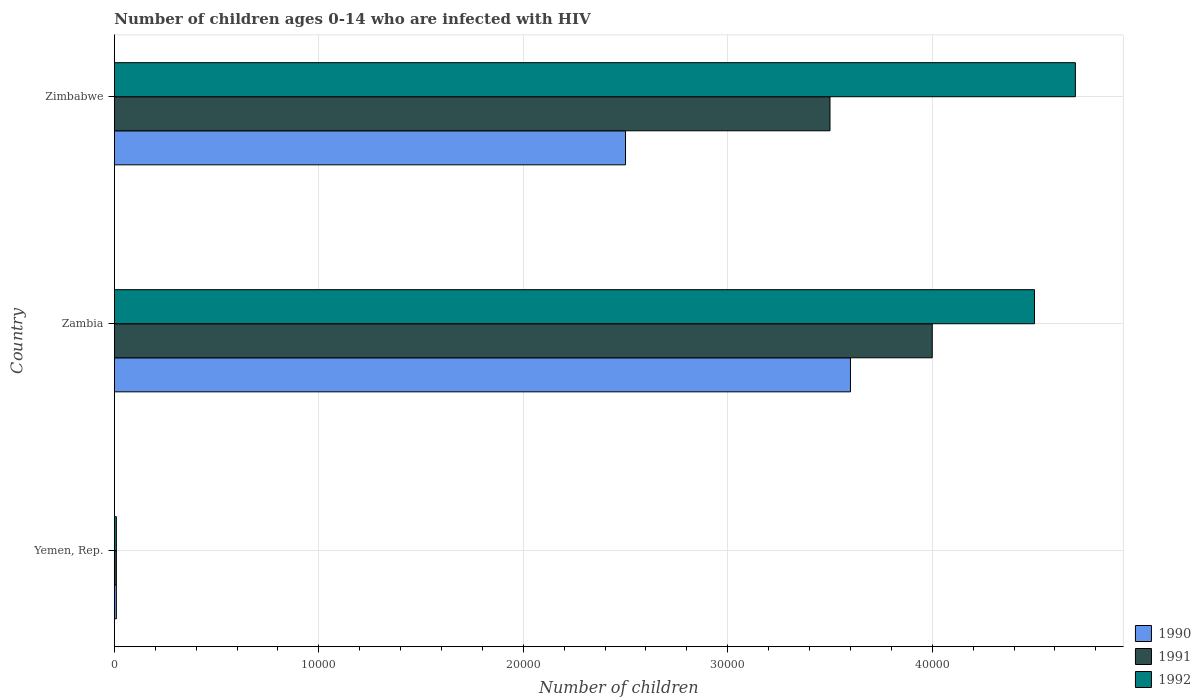How many bars are there on the 1st tick from the top?
Offer a very short reply. 3. What is the label of the 3rd group of bars from the top?
Your answer should be compact. Yemen, Rep. In how many cases, is the number of bars for a given country not equal to the number of legend labels?
Ensure brevity in your answer.  0. What is the number of HIV infected children in 1991 in Zimbabwe?
Offer a very short reply. 3.50e+04. Across all countries, what is the maximum number of HIV infected children in 1992?
Provide a short and direct response. 4.70e+04. Across all countries, what is the minimum number of HIV infected children in 1991?
Offer a terse response. 100. In which country was the number of HIV infected children in 1992 maximum?
Your answer should be very brief. Zimbabwe. In which country was the number of HIV infected children in 1992 minimum?
Keep it short and to the point. Yemen, Rep. What is the total number of HIV infected children in 1992 in the graph?
Offer a very short reply. 9.21e+04. What is the difference between the number of HIV infected children in 1990 in Yemen, Rep. and that in Zimbabwe?
Your response must be concise. -2.49e+04. What is the difference between the number of HIV infected children in 1992 in Yemen, Rep. and the number of HIV infected children in 1990 in Zambia?
Provide a succinct answer. -3.59e+04. What is the average number of HIV infected children in 1990 per country?
Keep it short and to the point. 2.04e+04. What is the difference between the number of HIV infected children in 1990 and number of HIV infected children in 1991 in Zambia?
Give a very brief answer. -4000. What is the ratio of the number of HIV infected children in 1991 in Yemen, Rep. to that in Zambia?
Keep it short and to the point. 0. Is the number of HIV infected children in 1990 in Yemen, Rep. less than that in Zimbabwe?
Your answer should be very brief. Yes. Is the difference between the number of HIV infected children in 1990 in Yemen, Rep. and Zambia greater than the difference between the number of HIV infected children in 1991 in Yemen, Rep. and Zambia?
Ensure brevity in your answer.  Yes. What is the difference between the highest and the second highest number of HIV infected children in 1990?
Make the answer very short. 1.10e+04. What is the difference between the highest and the lowest number of HIV infected children in 1990?
Keep it short and to the point. 3.59e+04. In how many countries, is the number of HIV infected children in 1991 greater than the average number of HIV infected children in 1991 taken over all countries?
Provide a succinct answer. 2. Is the sum of the number of HIV infected children in 1992 in Yemen, Rep. and Zimbabwe greater than the maximum number of HIV infected children in 1991 across all countries?
Provide a short and direct response. Yes. What does the 2nd bar from the top in Yemen, Rep. represents?
Ensure brevity in your answer.  1991. How many bars are there?
Provide a succinct answer. 9. How many countries are there in the graph?
Give a very brief answer. 3. What is the difference between two consecutive major ticks on the X-axis?
Provide a succinct answer. 10000. Are the values on the major ticks of X-axis written in scientific E-notation?
Your answer should be very brief. No. Does the graph contain any zero values?
Your answer should be compact. No. Does the graph contain grids?
Your response must be concise. Yes. How are the legend labels stacked?
Your answer should be very brief. Vertical. What is the title of the graph?
Your answer should be compact. Number of children ages 0-14 who are infected with HIV. Does "2000" appear as one of the legend labels in the graph?
Offer a very short reply. No. What is the label or title of the X-axis?
Your answer should be compact. Number of children. What is the label or title of the Y-axis?
Your response must be concise. Country. What is the Number of children of 1990 in Yemen, Rep.?
Keep it short and to the point. 100. What is the Number of children in 1992 in Yemen, Rep.?
Your response must be concise. 100. What is the Number of children in 1990 in Zambia?
Your answer should be compact. 3.60e+04. What is the Number of children of 1991 in Zambia?
Give a very brief answer. 4.00e+04. What is the Number of children of 1992 in Zambia?
Offer a very short reply. 4.50e+04. What is the Number of children of 1990 in Zimbabwe?
Make the answer very short. 2.50e+04. What is the Number of children in 1991 in Zimbabwe?
Ensure brevity in your answer.  3.50e+04. What is the Number of children in 1992 in Zimbabwe?
Offer a very short reply. 4.70e+04. Across all countries, what is the maximum Number of children of 1990?
Offer a terse response. 3.60e+04. Across all countries, what is the maximum Number of children in 1992?
Your response must be concise. 4.70e+04. What is the total Number of children of 1990 in the graph?
Keep it short and to the point. 6.11e+04. What is the total Number of children in 1991 in the graph?
Your response must be concise. 7.51e+04. What is the total Number of children in 1992 in the graph?
Offer a terse response. 9.21e+04. What is the difference between the Number of children of 1990 in Yemen, Rep. and that in Zambia?
Offer a very short reply. -3.59e+04. What is the difference between the Number of children of 1991 in Yemen, Rep. and that in Zambia?
Offer a very short reply. -3.99e+04. What is the difference between the Number of children of 1992 in Yemen, Rep. and that in Zambia?
Offer a terse response. -4.49e+04. What is the difference between the Number of children of 1990 in Yemen, Rep. and that in Zimbabwe?
Offer a terse response. -2.49e+04. What is the difference between the Number of children of 1991 in Yemen, Rep. and that in Zimbabwe?
Ensure brevity in your answer.  -3.49e+04. What is the difference between the Number of children of 1992 in Yemen, Rep. and that in Zimbabwe?
Give a very brief answer. -4.69e+04. What is the difference between the Number of children in 1990 in Zambia and that in Zimbabwe?
Provide a short and direct response. 1.10e+04. What is the difference between the Number of children of 1991 in Zambia and that in Zimbabwe?
Ensure brevity in your answer.  5000. What is the difference between the Number of children of 1992 in Zambia and that in Zimbabwe?
Make the answer very short. -2000. What is the difference between the Number of children in 1990 in Yemen, Rep. and the Number of children in 1991 in Zambia?
Your response must be concise. -3.99e+04. What is the difference between the Number of children in 1990 in Yemen, Rep. and the Number of children in 1992 in Zambia?
Your answer should be very brief. -4.49e+04. What is the difference between the Number of children in 1991 in Yemen, Rep. and the Number of children in 1992 in Zambia?
Offer a terse response. -4.49e+04. What is the difference between the Number of children in 1990 in Yemen, Rep. and the Number of children in 1991 in Zimbabwe?
Your answer should be very brief. -3.49e+04. What is the difference between the Number of children in 1990 in Yemen, Rep. and the Number of children in 1992 in Zimbabwe?
Your answer should be very brief. -4.69e+04. What is the difference between the Number of children of 1991 in Yemen, Rep. and the Number of children of 1992 in Zimbabwe?
Provide a short and direct response. -4.69e+04. What is the difference between the Number of children of 1990 in Zambia and the Number of children of 1992 in Zimbabwe?
Ensure brevity in your answer.  -1.10e+04. What is the difference between the Number of children of 1991 in Zambia and the Number of children of 1992 in Zimbabwe?
Provide a succinct answer. -7000. What is the average Number of children of 1990 per country?
Offer a terse response. 2.04e+04. What is the average Number of children of 1991 per country?
Offer a terse response. 2.50e+04. What is the average Number of children in 1992 per country?
Your answer should be compact. 3.07e+04. What is the difference between the Number of children of 1990 and Number of children of 1991 in Yemen, Rep.?
Give a very brief answer. 0. What is the difference between the Number of children of 1990 and Number of children of 1991 in Zambia?
Your answer should be very brief. -4000. What is the difference between the Number of children in 1990 and Number of children in 1992 in Zambia?
Your response must be concise. -9000. What is the difference between the Number of children in 1991 and Number of children in 1992 in Zambia?
Offer a terse response. -5000. What is the difference between the Number of children in 1990 and Number of children in 1992 in Zimbabwe?
Offer a terse response. -2.20e+04. What is the difference between the Number of children of 1991 and Number of children of 1992 in Zimbabwe?
Your response must be concise. -1.20e+04. What is the ratio of the Number of children of 1990 in Yemen, Rep. to that in Zambia?
Your answer should be very brief. 0. What is the ratio of the Number of children in 1991 in Yemen, Rep. to that in Zambia?
Your answer should be compact. 0. What is the ratio of the Number of children in 1992 in Yemen, Rep. to that in Zambia?
Give a very brief answer. 0. What is the ratio of the Number of children of 1990 in Yemen, Rep. to that in Zimbabwe?
Offer a very short reply. 0. What is the ratio of the Number of children of 1991 in Yemen, Rep. to that in Zimbabwe?
Provide a short and direct response. 0. What is the ratio of the Number of children of 1992 in Yemen, Rep. to that in Zimbabwe?
Your answer should be very brief. 0. What is the ratio of the Number of children of 1990 in Zambia to that in Zimbabwe?
Your answer should be compact. 1.44. What is the ratio of the Number of children of 1991 in Zambia to that in Zimbabwe?
Ensure brevity in your answer.  1.14. What is the ratio of the Number of children in 1992 in Zambia to that in Zimbabwe?
Offer a very short reply. 0.96. What is the difference between the highest and the second highest Number of children of 1990?
Your answer should be very brief. 1.10e+04. What is the difference between the highest and the second highest Number of children of 1991?
Keep it short and to the point. 5000. What is the difference between the highest and the lowest Number of children of 1990?
Make the answer very short. 3.59e+04. What is the difference between the highest and the lowest Number of children in 1991?
Keep it short and to the point. 3.99e+04. What is the difference between the highest and the lowest Number of children in 1992?
Your response must be concise. 4.69e+04. 